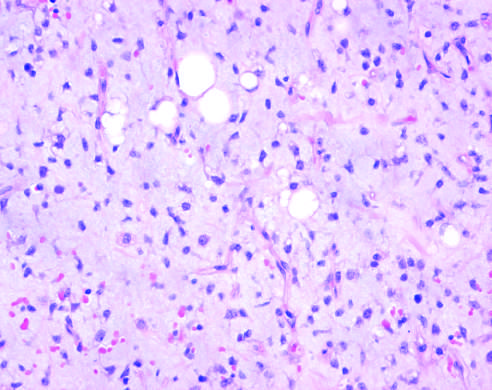what are there in myxoid liposarcoma with abundant ground substance and a rich capillary network?
Answer the question using a single word or phrase. Scattered immature adipocytes and more primitive round-to-stellate cells 